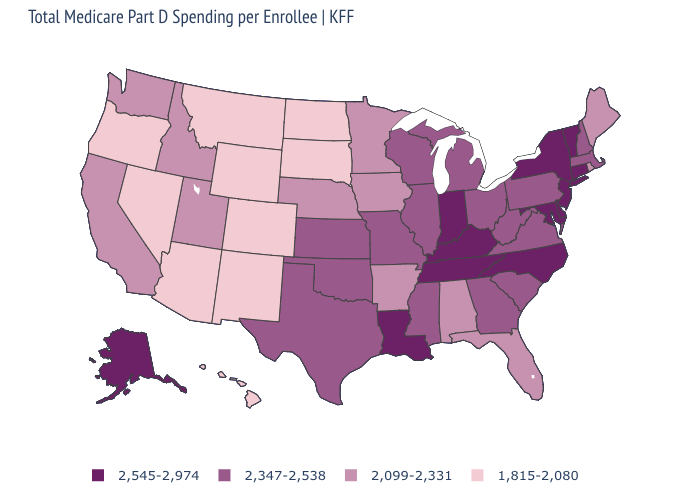Which states hav the highest value in the South?
Be succinct. Delaware, Kentucky, Louisiana, Maryland, North Carolina, Tennessee. Does the map have missing data?
Answer briefly. No. How many symbols are there in the legend?
Give a very brief answer. 4. Name the states that have a value in the range 2,545-2,974?
Answer briefly. Alaska, Connecticut, Delaware, Indiana, Kentucky, Louisiana, Maryland, New Jersey, New York, North Carolina, Tennessee, Vermont. Name the states that have a value in the range 1,815-2,080?
Answer briefly. Arizona, Colorado, Hawaii, Montana, Nevada, New Mexico, North Dakota, Oregon, South Dakota, Wyoming. Which states hav the highest value in the West?
Concise answer only. Alaska. What is the value of New Mexico?
Short answer required. 1,815-2,080. Does the map have missing data?
Concise answer only. No. Does Kentucky have the lowest value in the USA?
Quick response, please. No. Name the states that have a value in the range 1,815-2,080?
Be succinct. Arizona, Colorado, Hawaii, Montana, Nevada, New Mexico, North Dakota, Oregon, South Dakota, Wyoming. What is the value of Alabama?
Write a very short answer. 2,099-2,331. What is the highest value in states that border Maryland?
Short answer required. 2,545-2,974. Among the states that border Missouri , does Illinois have the lowest value?
Be succinct. No. What is the lowest value in states that border Maine?
Answer briefly. 2,347-2,538. What is the value of Nebraska?
Keep it brief. 2,099-2,331. 